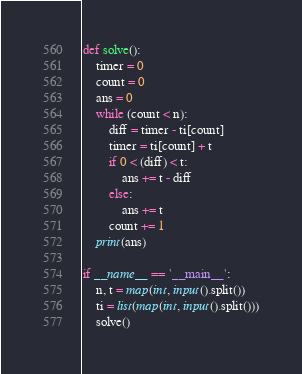Convert code to text. <code><loc_0><loc_0><loc_500><loc_500><_Python_>

def solve():
    timer = 0
    count = 0
    ans = 0
    while (count < n):
        diff = timer - ti[count]
        timer = ti[count] + t
        if 0 < (diff) < t:
            ans += t - diff
        else:
            ans += t
        count += 1
    print(ans)

if __name__ == '__main__':
    n, t = map(int, input().split())
    ti = list(map(int, input().split()))
    solve()</code> 